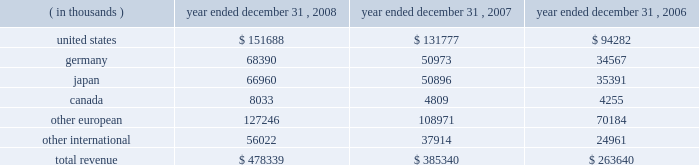15 .
Leases in january 1996 , the company entered into a lease agreement with an unrelated third party for a new corporate office facility , which the company occupied in february 1997 .
In may 2004 , the company entered into the first amendment to this lease agreement , effective january 1 , 2004 .
The lease was extended from an original period of 10 years , with an option for five additional years , to a period of 18 years from the inception date , with an option for five additional years .
The company incurred lease rental expense related to this facility of $ 1.3 million in 2008 , 2007 and 2006 .
The future minimum lease payments are $ 1.4 million per annum from january 1 , 2009 to december 31 , 2014 .
The future minimum lease payments from january 1 , 2015 through december 31 , 2019 will be determined based on prevailing market rental rates at the time of the extension , if elected .
The amended lease also provided for the lessor to reimburse the company for up to $ 550000 in building refurbishments completed through march 31 , 2006 .
These amounts have been recorded as a reduction of lease expense over the remaining term of the lease .
The company has also entered into various noncancellable operating leases for equipment and office space .
Office space lease expense totaled $ 9.3 million , $ 6.3 million and $ 4.7 million for the years ended december 31 , 2008 , 2007 and 2006 , respectively .
Future minimum lease payments under noncancellable operating leases for office space in effect at december 31 , 2008 are $ 8.8 million in 2009 , $ 6.6 million in 2010 , $ 3.0 million in 2011 , $ 1.8 million in 2012 and $ 1.1 million in 2013 .
16 .
Royalty agreements the company has entered into various renewable , nonexclusive license agreements under which the company has been granted access to the licensor 2019s technology and the right to sell the technology in the company 2019s product line .
Royalties are payable to developers of the software at various rates and amounts , which generally are based upon unit sales or revenue .
Royalty fees are reported in cost of goods sold and were $ 6.3 million , $ 5.2 million and $ 3.9 million for the years ended december 31 , 2008 , 2007 and 2006 , respectively .
17 .
Geographic information revenue to external customers is attributed to individual countries based upon the location of the customer .
Revenue by geographic area is as follows: .

What was the average future minimum lease payments under noncancellable operating leases for office space from 2009 to 2013 in millions .? 
Computations: (((((8.8 + 6.6) + 3.0) + 1.8) + 1.1) / 4)
Answer: 5.325. 